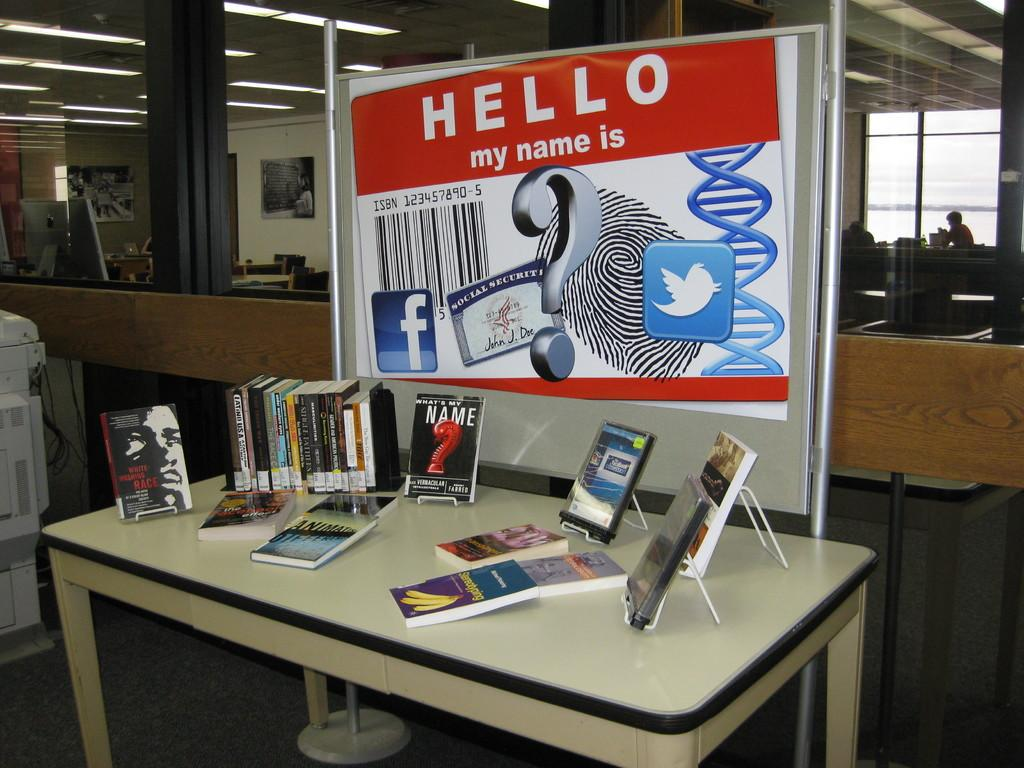<image>
Summarize the visual content of the image. A display of books below a sign that says "Hello my name is" 